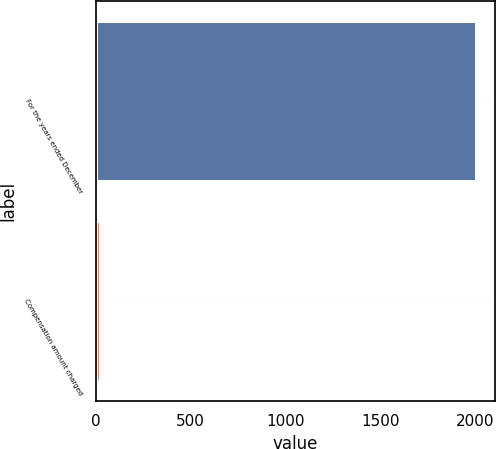<chart> <loc_0><loc_0><loc_500><loc_500><bar_chart><fcel>For the years ended December<fcel>Compensation amount charged<nl><fcel>2005<fcel>19.9<nl></chart> 